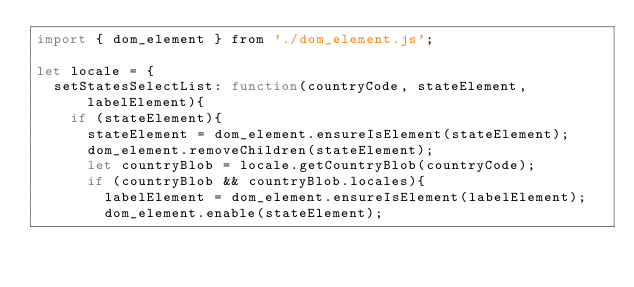Convert code to text. <code><loc_0><loc_0><loc_500><loc_500><_JavaScript_>import { dom_element } from './dom_element.js';

let locale = {
	setStatesSelectList: function(countryCode, stateElement, labelElement){
		if (stateElement){
			stateElement = dom_element.ensureIsElement(stateElement);
			dom_element.removeChildren(stateElement);
			let countryBlob = locale.getCountryBlob(countryCode);
			if (countryBlob && countryBlob.locales){
				labelElement = dom_element.ensureIsElement(labelElement);
				dom_element.enable(stateElement);</code> 